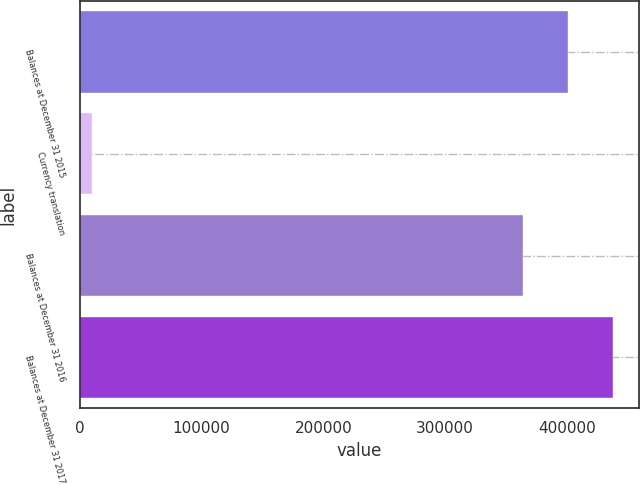Convert chart to OTSL. <chart><loc_0><loc_0><loc_500><loc_500><bar_chart><fcel>Balances at December 31 2015<fcel>Currency translation<fcel>Balances at December 31 2016<fcel>Balances at December 31 2017<nl><fcel>400724<fcel>10055<fcel>363978<fcel>437471<nl></chart> 